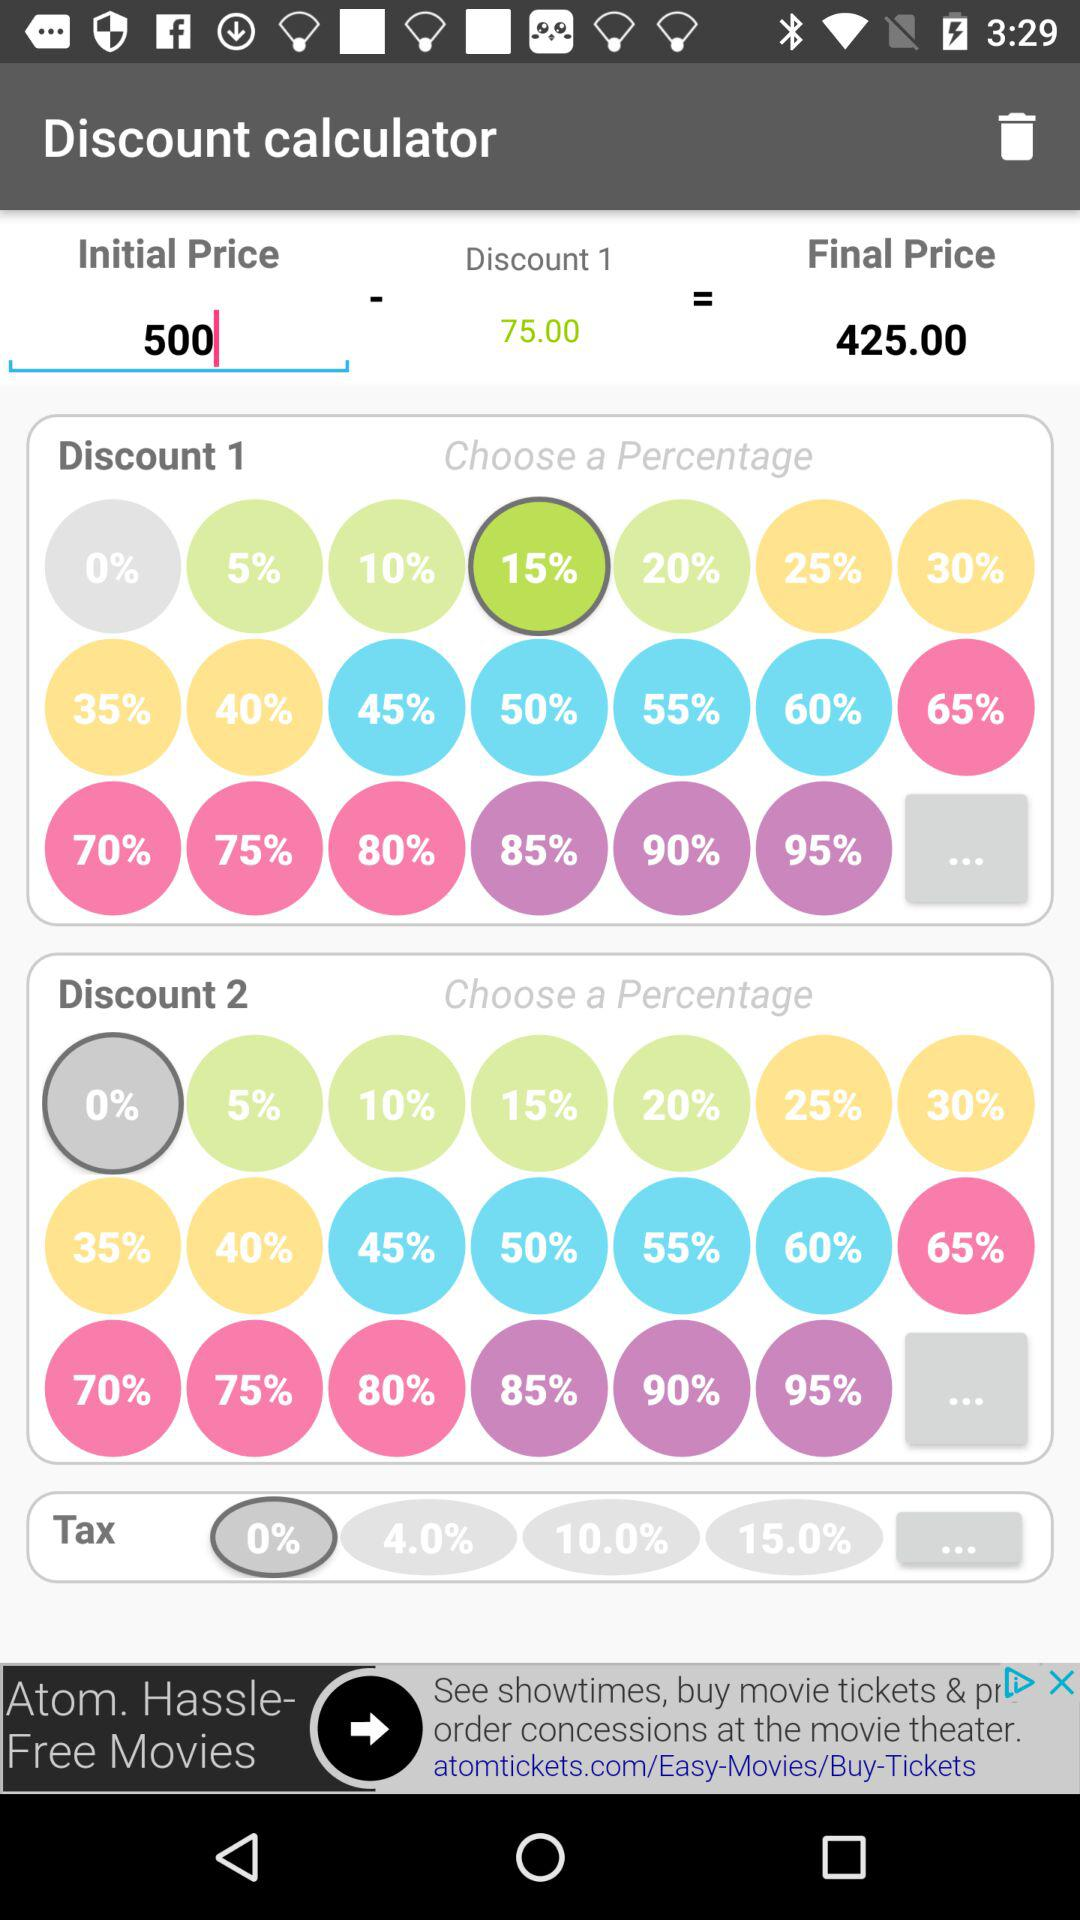How much is the tax on discount 2?
When the provided information is insufficient, respond with <no answer>. <no answer> 